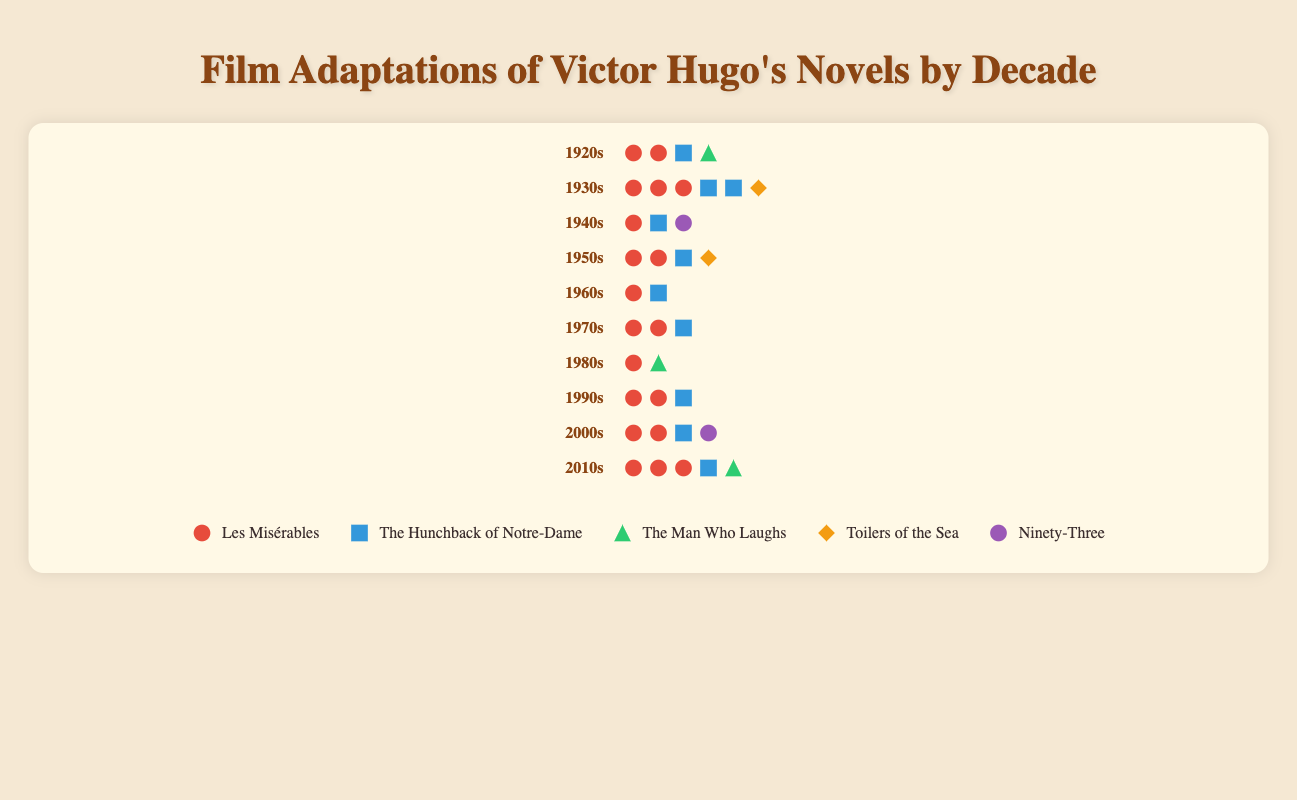What is the total number of film adaptations for Les Misérables in the 2010s? Count the icons representing Les Misérables in the 2010s row.
Answer: 3 How did the number of adaptations of The Man Who Laughs change between the 2000s and the 2010s? Compare the number of icons for The Man Who Laughs in the 2000s and the 2010s rows.
Answer: Increased by 1 Which novel had at least one film adaptation in every decade? Check each novel's adaptation count across all decades; only Les Misérables has no zeros.
Answer: Les Misérables How many total adaptations were produced in the 1930s across all novels? Sum the number of adaptations for each novel in the 1930s row. 3 (Les Misérables) + 2 (The Hunchback of Notre-Dame) + 0 (The Man Who Laughs) + 1 (Toilers of the Sea) + 0 (Ninety-Three) = 6
Answer: 6 Which decade saw the highest total number of adaptations for Victor Hugo's novels? Add the adaptation counts for all novels in each decade and compare. The decade with the highest total sum is the 1930s (6 from Les Misérables, The Hunchback of Notre-Dame, and Toilers of the Sea).
Answer: 1930s Did any novel other than Les Misérables ever have more than 2 adaptations in a single decade? Examine each novel's adaptation counts per decade. Only Les Misérables had more than 2 adaptations in a single decade.
Answer: No What is the average number of adaptations of The Hunchback of Notre-Dame over the decades? Sum the total adaptations of The Hunchback of Notre-Dame and divide by the number of decades (1+2+1+1+1+1+0+1+1+1=10; 10/10=1).
Answer: 1 Which novel had the fewest total adaptations across all decades? Sum the total number of adaptations for each novel and compare. Ninety-Three (2 only) had the fewest.
Answer: Ninety-Three Compare the number of adaptations for Les Misérables and The Hunchback of Notre-Dame in the 1950s. Count the icons for both novels in the 1950s row and compare. Les Misérables has 2 adaptations, The Hunchback of Notre-Dame has 1 adaptation.
Answer: Les Misérables had more 